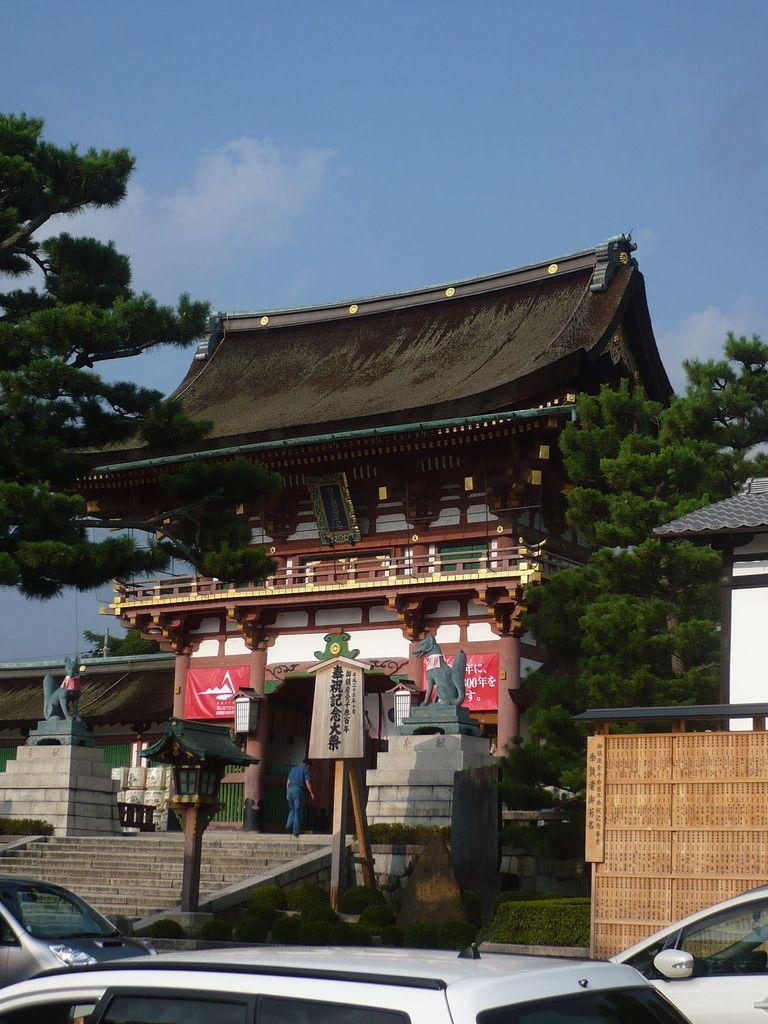What is the main structure in the image? There is a building in the image. What can be seen on both sides of the building? There are trees on either side of the building. What type of vehicles are in front of the building? There are cars in front of the building. Where is the daughter performing on stage in the image? There is no daughter or stage present in the image. What type of vessel is floating near the building in the image? There is no vessel present in the image; it only features a building, trees, and cars. 